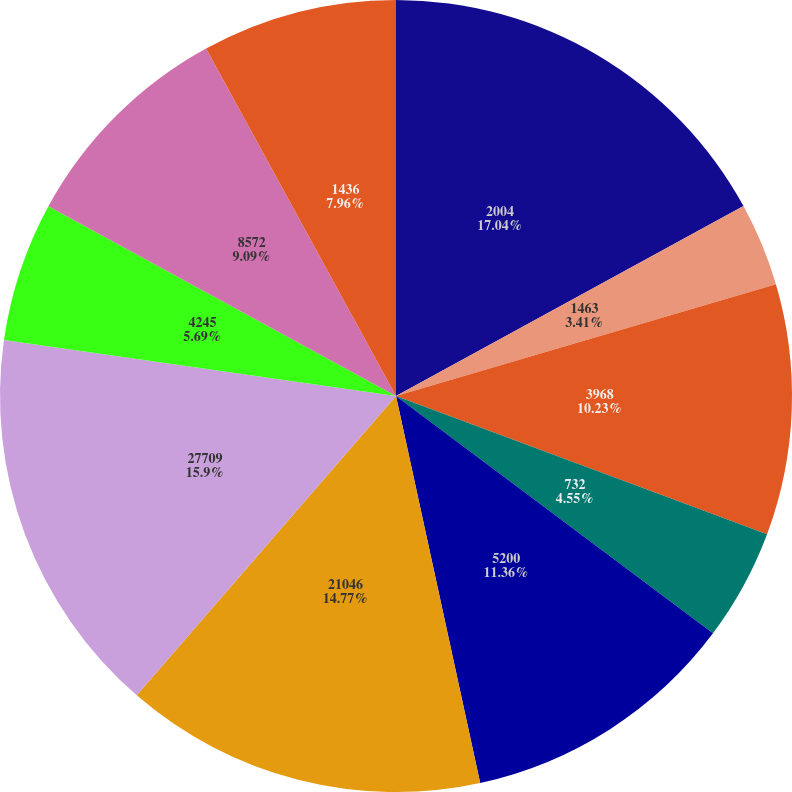<chart> <loc_0><loc_0><loc_500><loc_500><pie_chart><fcel>2004<fcel>1463<fcel>3968<fcel>732<fcel>5200<fcel>21046<fcel>27709<fcel>4245<fcel>8572<fcel>1436<nl><fcel>17.04%<fcel>3.41%<fcel>10.23%<fcel>4.55%<fcel>11.36%<fcel>14.77%<fcel>15.9%<fcel>5.69%<fcel>9.09%<fcel>7.96%<nl></chart> 